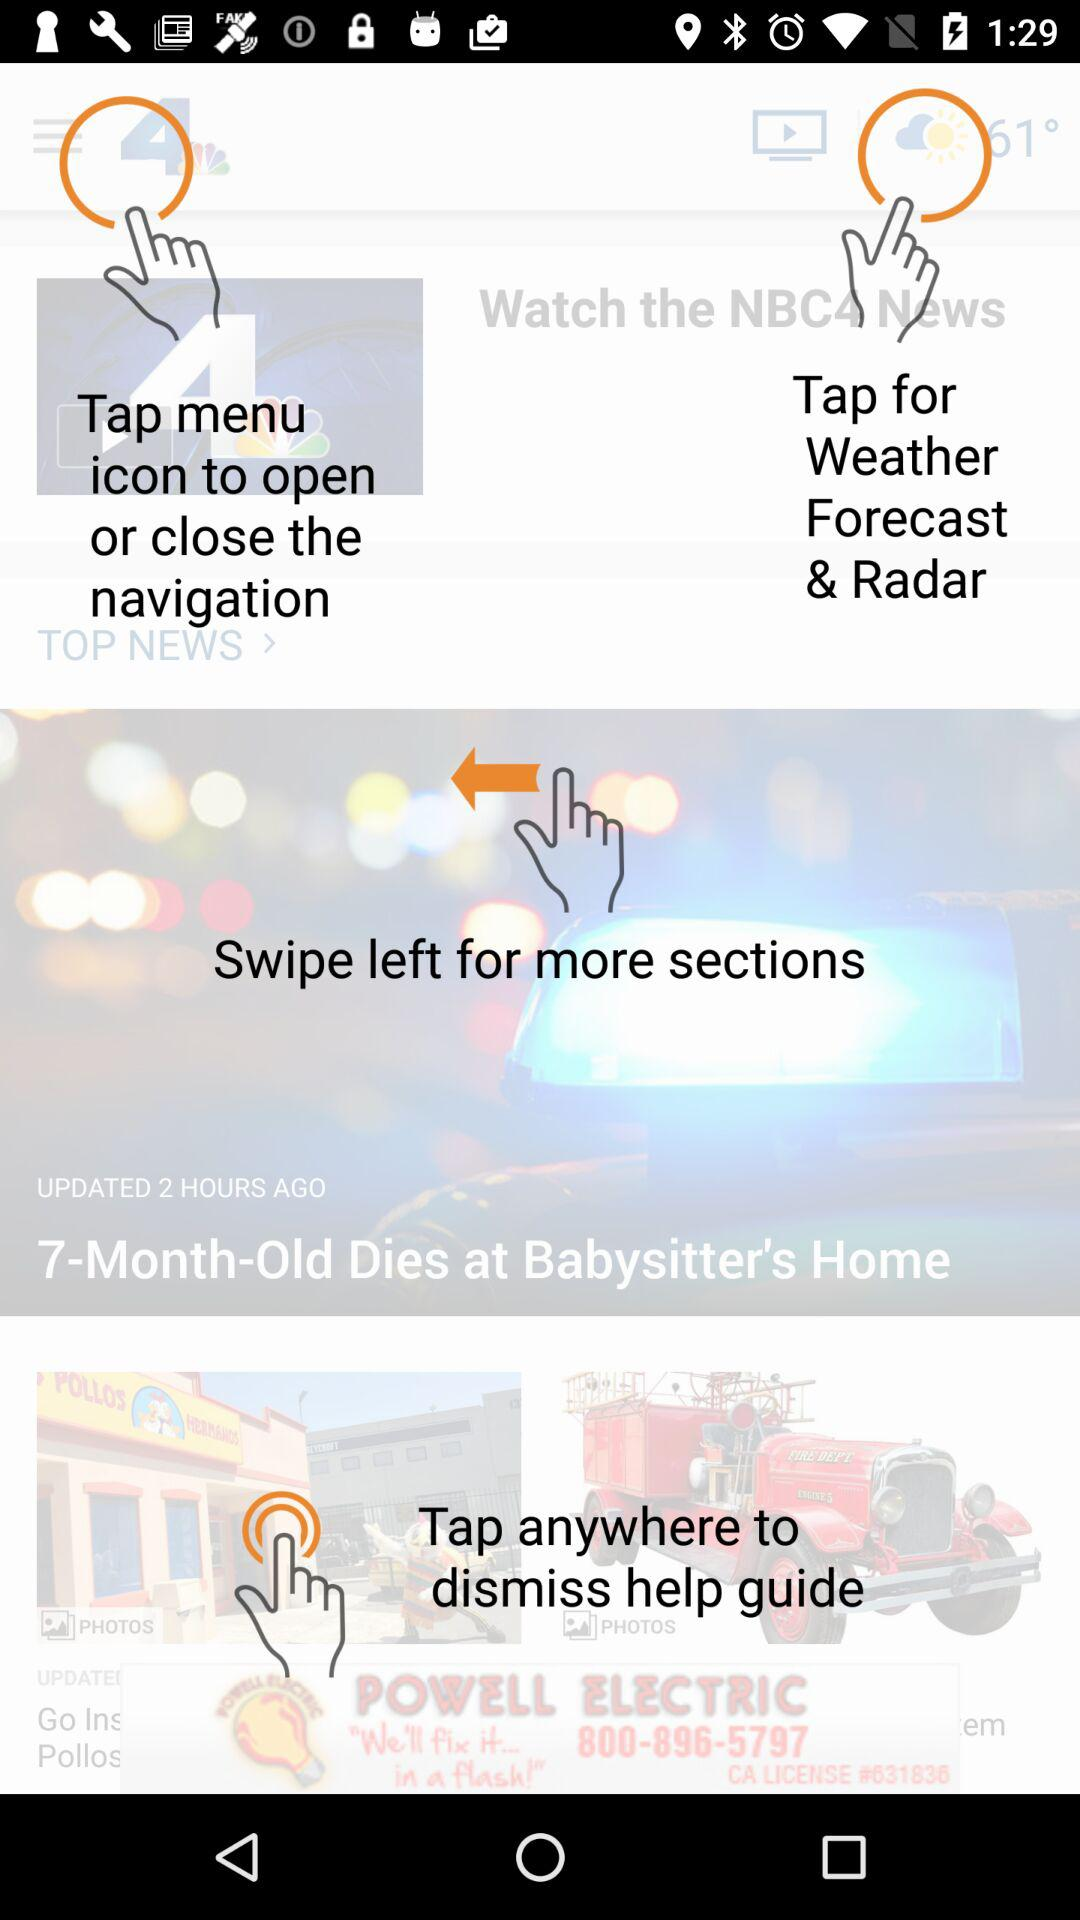What is the temperature? The temperature is 61°. 